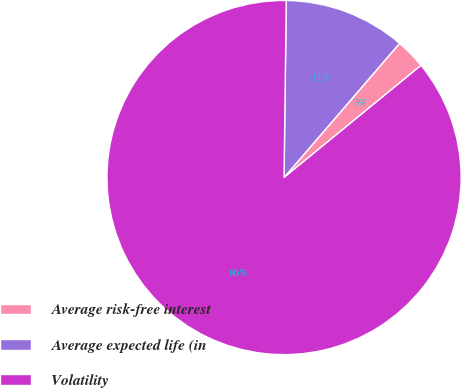Convert chart. <chart><loc_0><loc_0><loc_500><loc_500><pie_chart><fcel>Average risk-free interest<fcel>Average expected life (in<fcel>Volatility<nl><fcel>2.77%<fcel>11.11%<fcel>86.12%<nl></chart> 